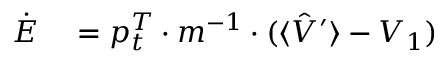<formula> <loc_0><loc_0><loc_500><loc_500>\begin{array} { r l } { \dot { E } } & = p _ { t } ^ { T } \cdot m ^ { - 1 } \cdot ( \langle \hat { V } ^ { \prime } \rangle - V _ { 1 } ) } \end{array}</formula> 